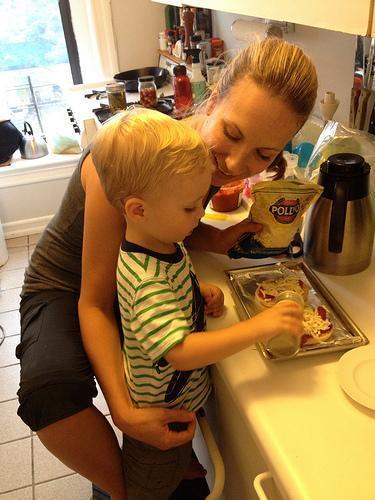How many people are the photo?
Give a very brief answer. 2. 